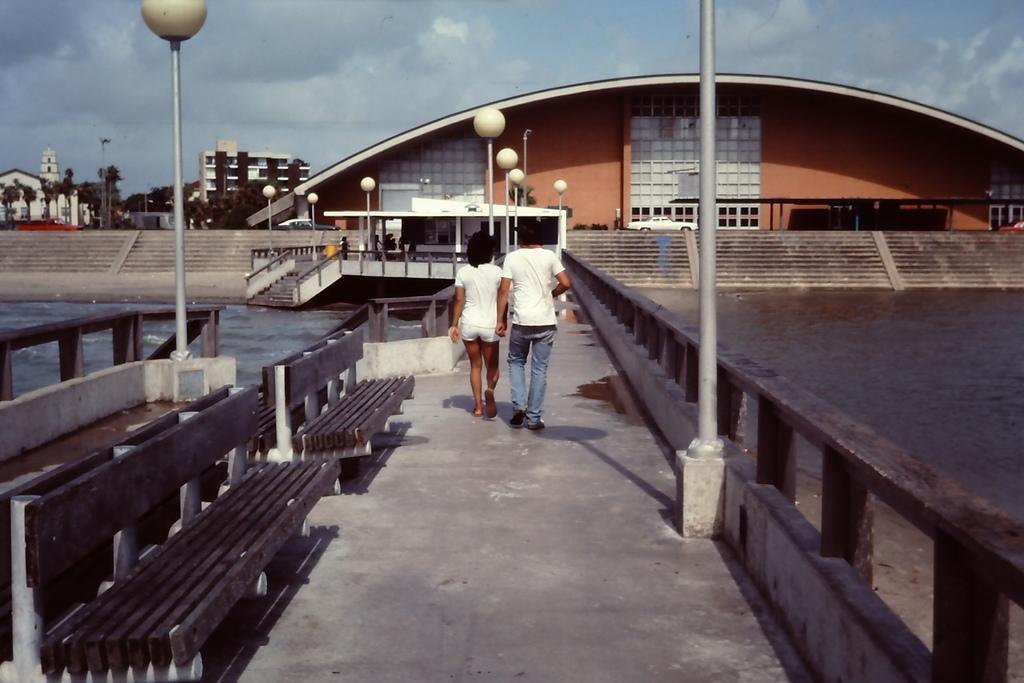Can you describe this image briefly? In this picture I can see buildings, trees and few pole lights and I can see water and a bridge and couple of the walking and I can see couple of benches and I can see stairs and a car and I can see a blue cloudy sky. 